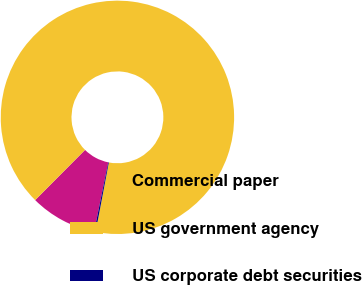Convert chart to OTSL. <chart><loc_0><loc_0><loc_500><loc_500><pie_chart><fcel>Commercial paper<fcel>US government agency<fcel>US corporate debt securities<nl><fcel>9.25%<fcel>90.54%<fcel>0.21%<nl></chart> 